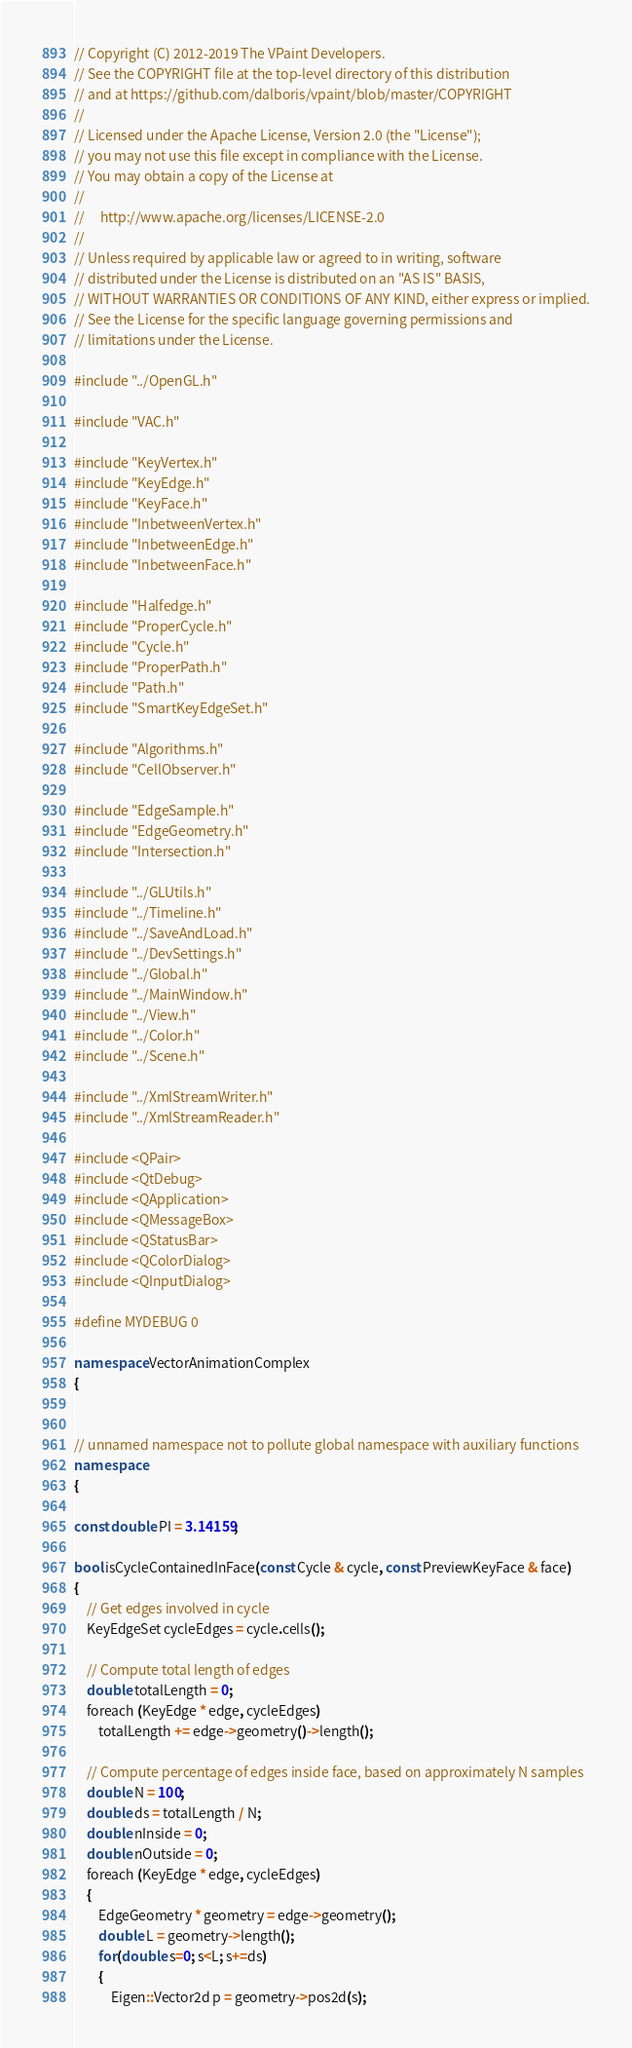<code> <loc_0><loc_0><loc_500><loc_500><_C++_>// Copyright (C) 2012-2019 The VPaint Developers.
// See the COPYRIGHT file at the top-level directory of this distribution
// and at https://github.com/dalboris/vpaint/blob/master/COPYRIGHT
//
// Licensed under the Apache License, Version 2.0 (the "License");
// you may not use this file except in compliance with the License.
// You may obtain a copy of the License at
//
//     http://www.apache.org/licenses/LICENSE-2.0
//
// Unless required by applicable law or agreed to in writing, software
// distributed under the License is distributed on an "AS IS" BASIS,
// WITHOUT WARRANTIES OR CONDITIONS OF ANY KIND, either express or implied.
// See the License for the specific language governing permissions and
// limitations under the License.

#include "../OpenGL.h"

#include "VAC.h"

#include "KeyVertex.h"
#include "KeyEdge.h"
#include "KeyFace.h"
#include "InbetweenVertex.h"
#include "InbetweenEdge.h"
#include "InbetweenFace.h"

#include "Halfedge.h"
#include "ProperCycle.h"
#include "Cycle.h"
#include "ProperPath.h"
#include "Path.h"
#include "SmartKeyEdgeSet.h"

#include "Algorithms.h"
#include "CellObserver.h"

#include "EdgeSample.h"
#include "EdgeGeometry.h"
#include "Intersection.h"

#include "../GLUtils.h"
#include "../Timeline.h"
#include "../SaveAndLoad.h"
#include "../DevSettings.h"
#include "../Global.h"
#include "../MainWindow.h"
#include "../View.h"
#include "../Color.h"
#include "../Scene.h"

#include "../XmlStreamWriter.h"
#include "../XmlStreamReader.h"

#include <QPair>
#include <QtDebug>
#include <QApplication>
#include <QMessageBox>
#include <QStatusBar>
#include <QColorDialog>
#include <QInputDialog>

#define MYDEBUG 0

namespace VectorAnimationComplex
{


// unnamed namespace not to pollute global namespace with auxiliary functions
namespace
{

const double PI = 3.14159;

bool isCycleContainedInFace(const Cycle & cycle, const PreviewKeyFace & face)
{
    // Get edges involved in cycle
    KeyEdgeSet cycleEdges = cycle.cells();

    // Compute total length of edges
    double totalLength = 0;
    foreach (KeyEdge * edge, cycleEdges)
        totalLength += edge->geometry()->length();

    // Compute percentage of edges inside face, based on approximately N samples
    double N = 100;
    double ds = totalLength / N;
    double nInside = 0;
    double nOutside = 0;
    foreach (KeyEdge * edge, cycleEdges)
    {
        EdgeGeometry * geometry = edge->geometry();
        double L = geometry->length();
        for(double s=0; s<L; s+=ds)
        {
            Eigen::Vector2d p = geometry->pos2d(s);</code> 